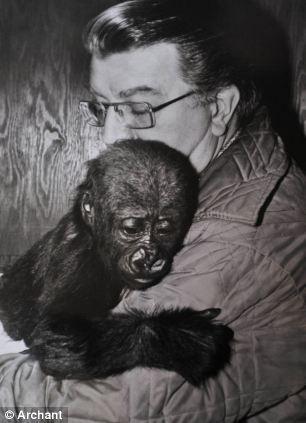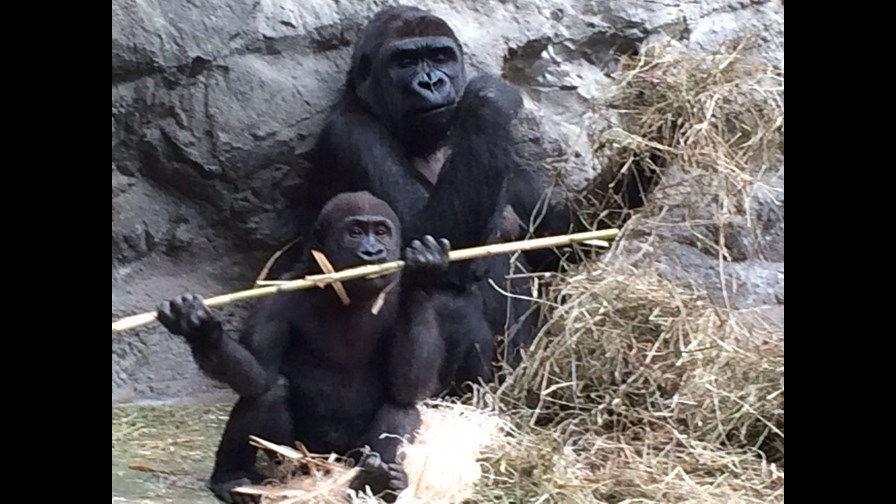The first image is the image on the left, the second image is the image on the right. Analyze the images presented: Is the assertion "One image shows a forward-gazing gorilla clutching at least one infant gorilla to its chest." valid? Answer yes or no. No. 